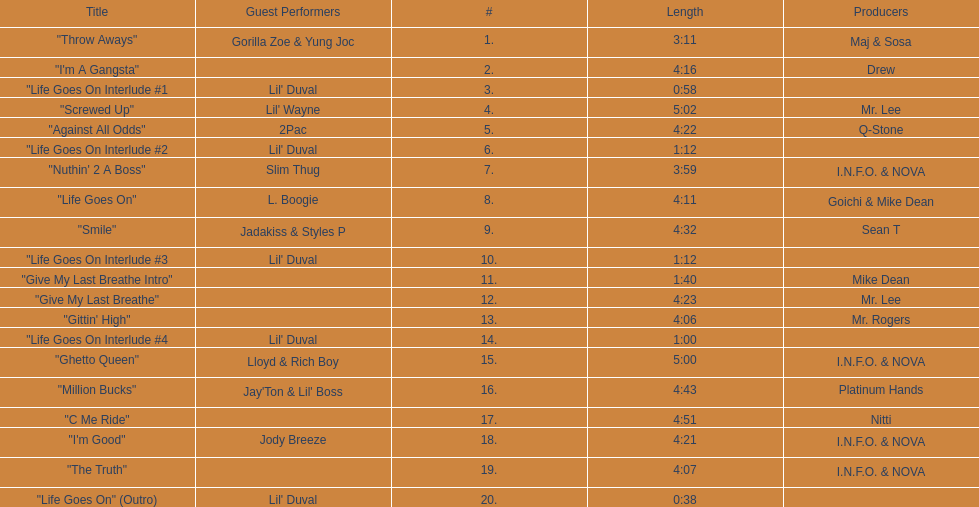What is the first track featuring lil' duval? "Life Goes On Interlude #1. 